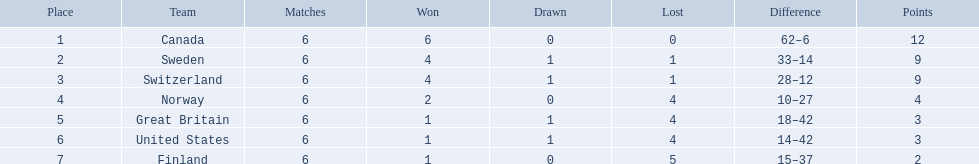What are all the squads? Canada, Sweden, Switzerland, Norway, Great Britain, United States, Finland. What were their points? 12, 9, 9, 4, 3, 3, 2. What about only switzerland and great britain? 9, 3. Now, which of those teams achieved a higher score? Switzerland. What are the two countries in question? Switzerland, Great Britain. What were their respective point tallies? 9, 3. Out of these tallies, which is more impressive? 9. Which country garnered this tally? Switzerland. 